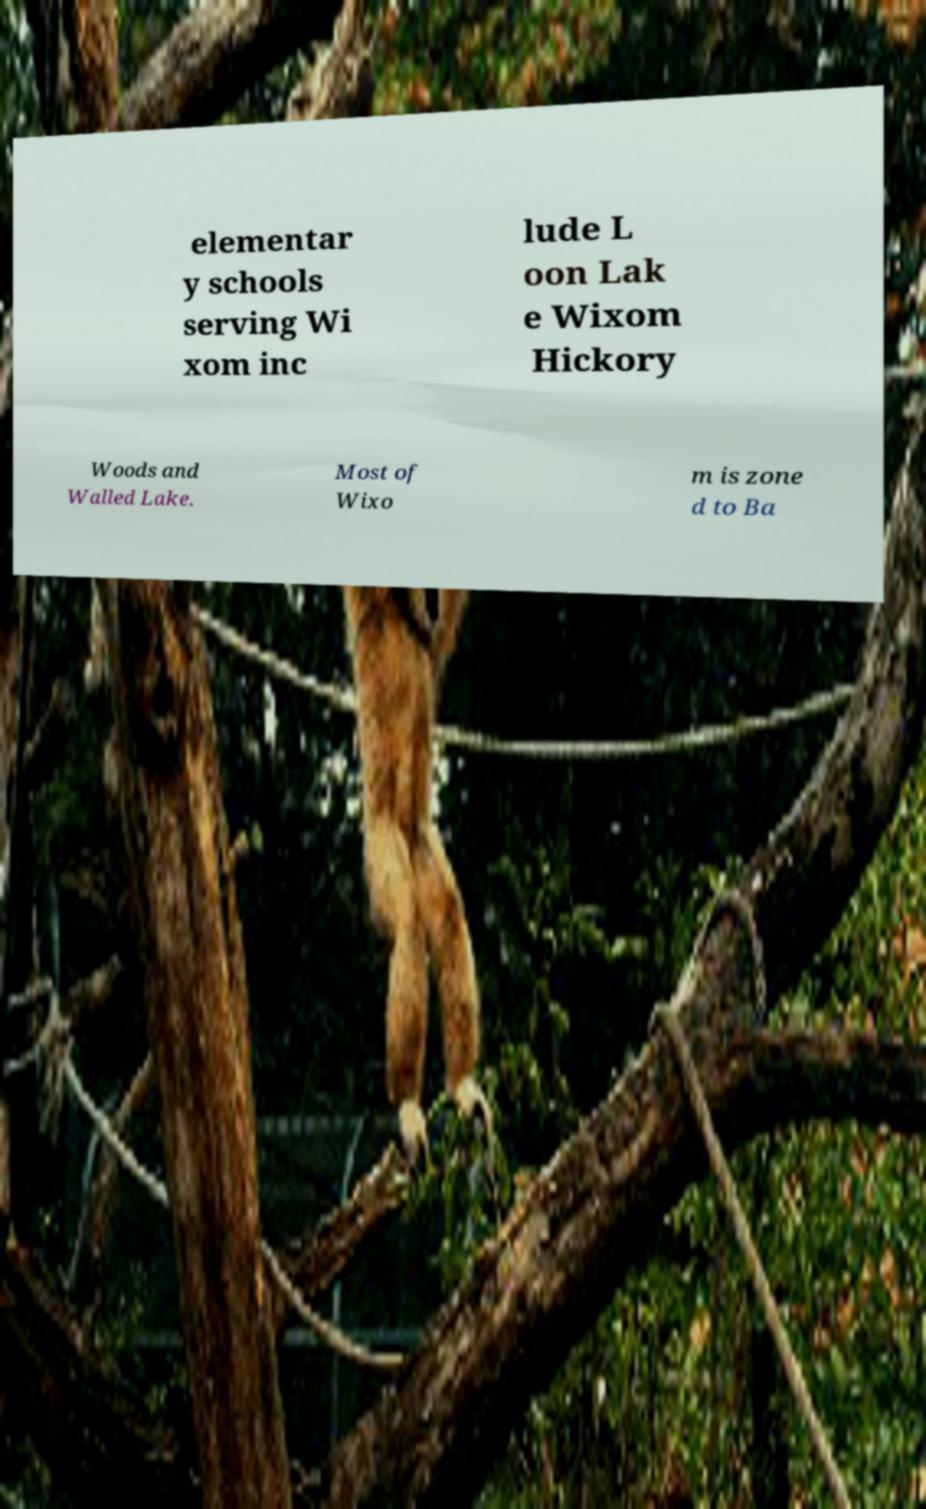Please read and relay the text visible in this image. What does it say? elementar y schools serving Wi xom inc lude L oon Lak e Wixom Hickory Woods and Walled Lake. Most of Wixo m is zone d to Ba 